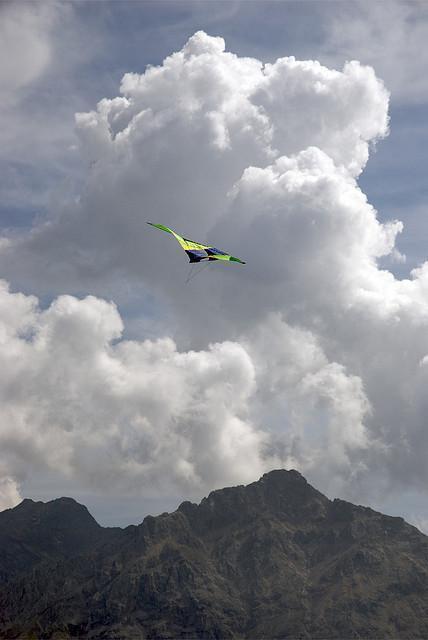How many kites are there?
Give a very brief answer. 1. 